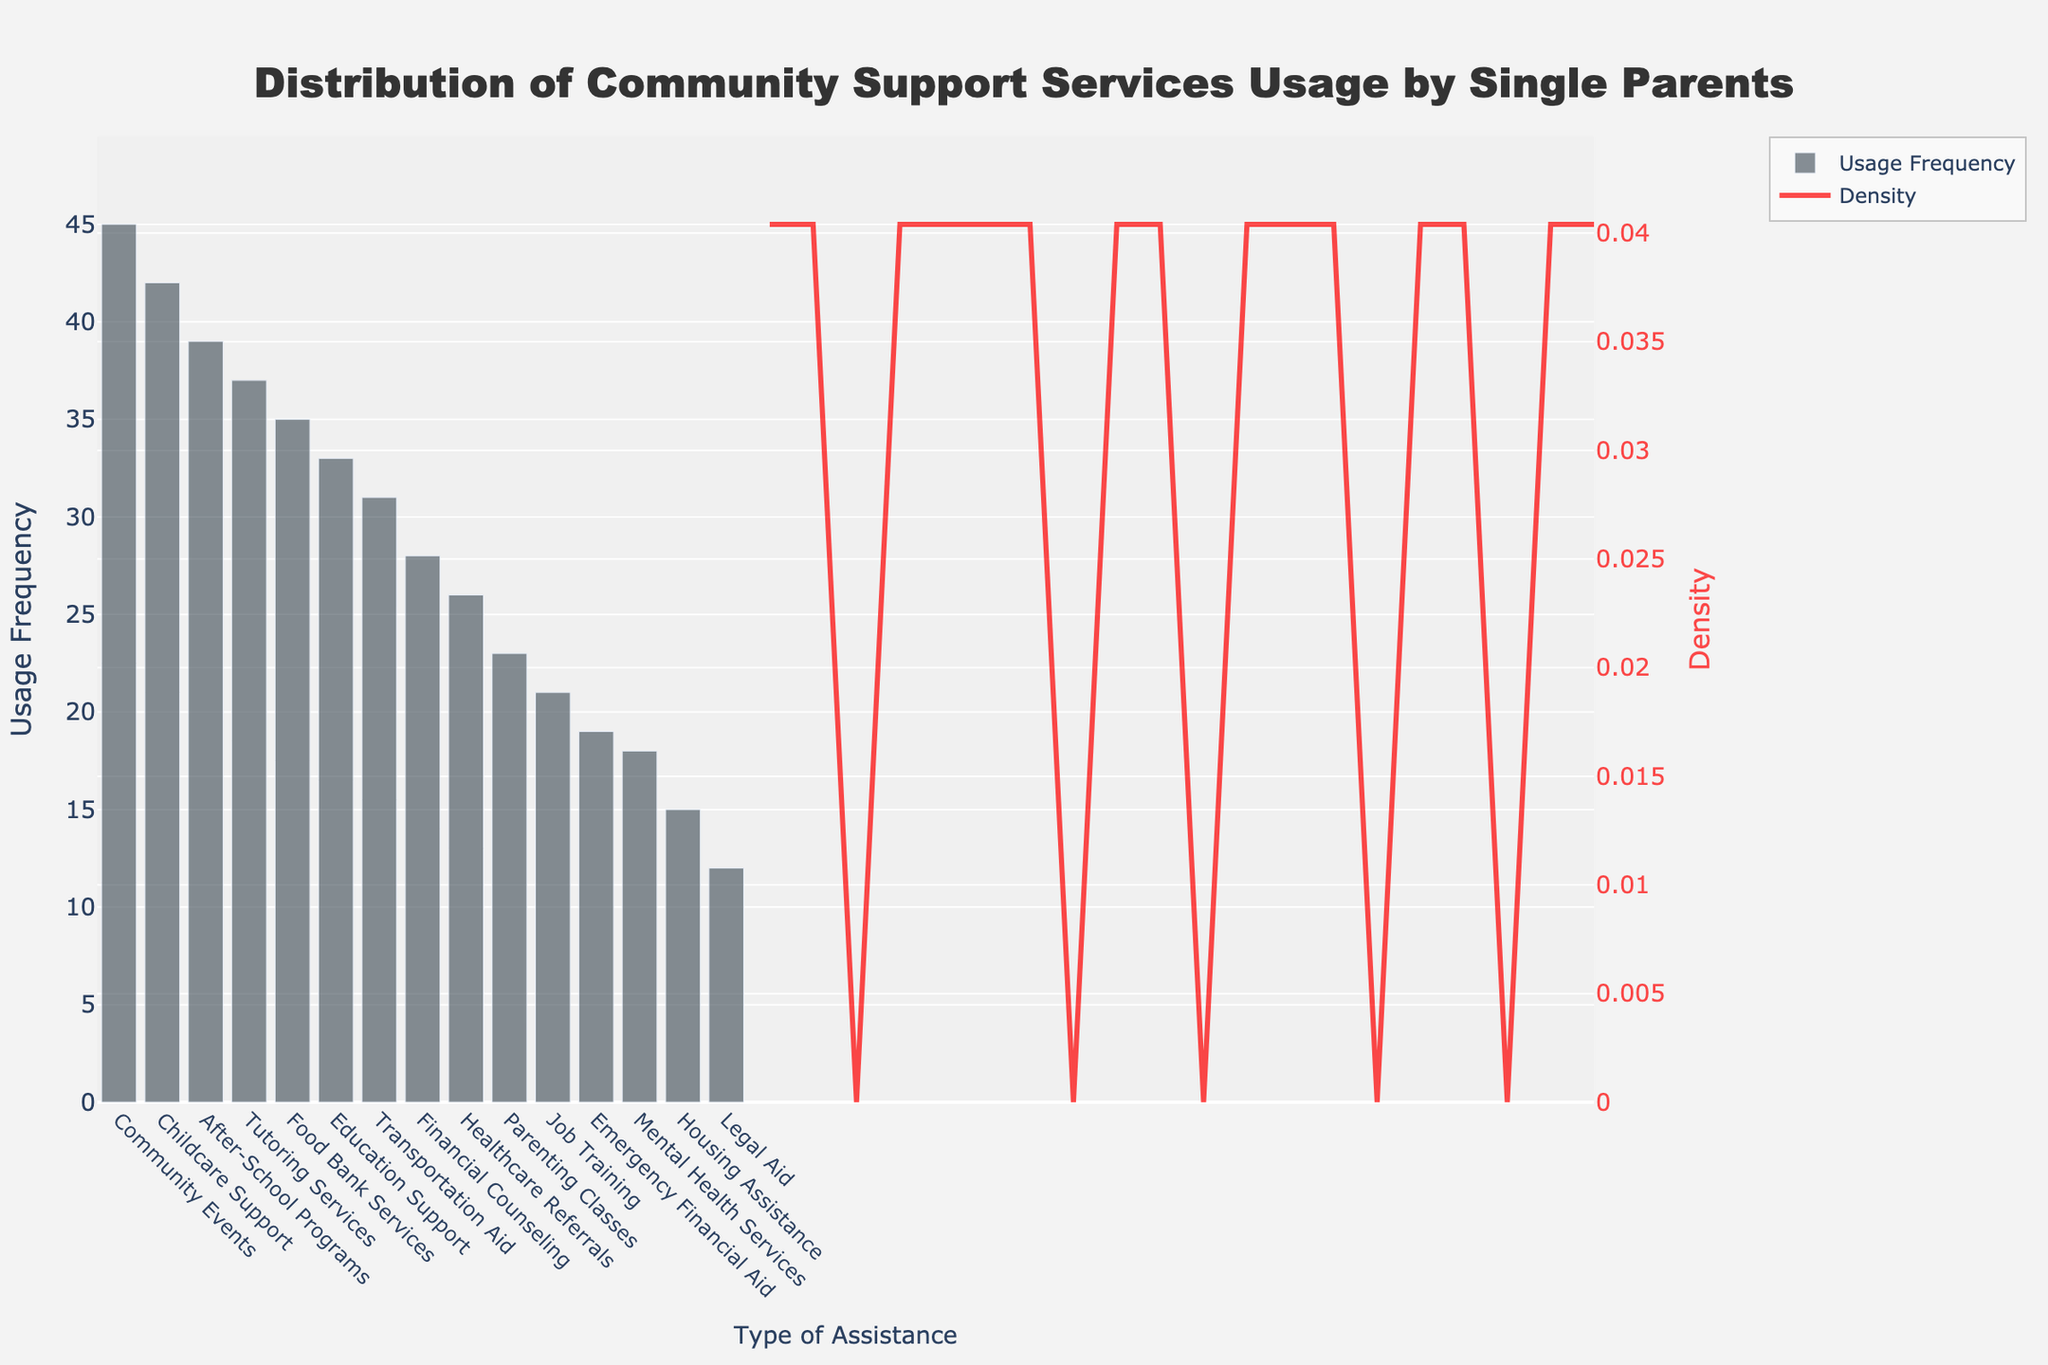What is the title of the figure? The title of the figure is displayed at the top and reads "Distribution of Community Support Services Usage by Single Parents".
Answer: Distribution of Community Support Services Usage by Single Parents What is the type of assistance with the highest usage frequency? The highest bar on the histogram represents "Community Events" which indicates the highest usage frequency.
Answer: Community Events How many types of assistance have a usage frequency greater than 30? To determine this, we count the bars that have heights surpassing the 30 mark on the y-axis. They are "Childcare Support", "After-School Programs", "Food Bank Services", "Tutoring Services", "Community Events", "Transportation Aid", and "Education Support". There are 7 such types.
Answer: 7 Which type of assistance has the lowest usage frequency? The shortest bar on the histogram corresponds to "Legal Aid", indicating the lowest usage frequency.
Answer: Legal Aid What is the range of the y-axis for usage frequency? The y-axis range can be identified by looking at the minimum and maximum limits on the y-axis of the histogram. It ranges from 0 to slightly above 45.
Answer: 0 to 45 What is the overall trend observed in the KDE curve? The KDE curve shows the density distribution of the usage frequencies. It starts high, dips slightly, and then rises again before tapering off, indicating a bimodal distribution in the data frequencies.
Answer: Bimodal distribution Which types of assistance have a usage frequency between 20 and 30? On the histogram, the bars within the 20 to 30 range on the y-axis represent "Financial Counseling", "Job Training", "Parenting Classes", "Healthcare Referrals", "Emergency Financial Aid", and "Education Support".
Answer: Financial Counseling, Job Training, Parenting Classes, Healthcare Referrals, Emergency Financial Aid, Education Support What is the mode of the usage frequencies? The mode is determined by looking at the highest peak on the KDE curve, which corresponds to the most common usage frequency. The peak does not provide exact values, but combining visual insights, you'd identify it around the high 30s due to the height of "Community Events", "Childcare Support", and others in the same range.
Answer: 30-40 What is the total combined usage frequency of "Mental Health Services" and "Housing Assistance"? Adding the usage frequencies of "Mental Health Services" (18) and "Housing Assistance" (15) gives a combined total of 33.
Answer: 33 What colors are used for the histogram bars and KDE curve? The bars of the histogram are colored in a dark bluish-gray, while the KDE curve is a noticeable red color.
Answer: Dark bluish-gray (bars) and red (KDE curve) 